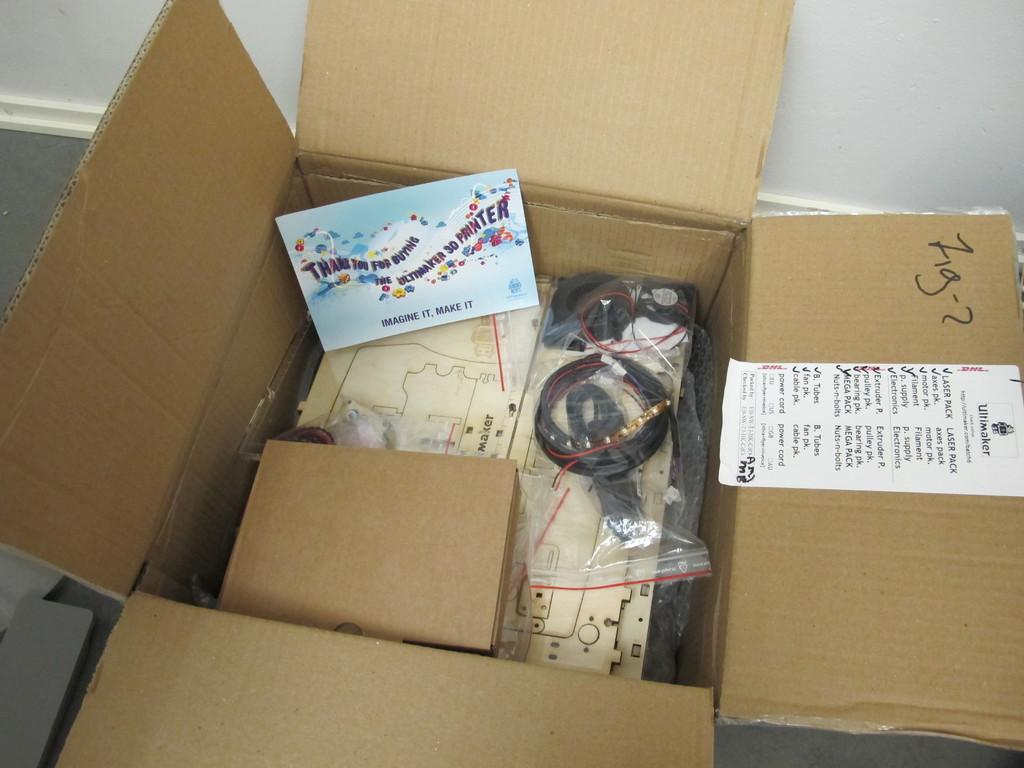<image>
Render a clear and concise summary of the photo. Brown Ultimaker box with a thank you for buying card. 